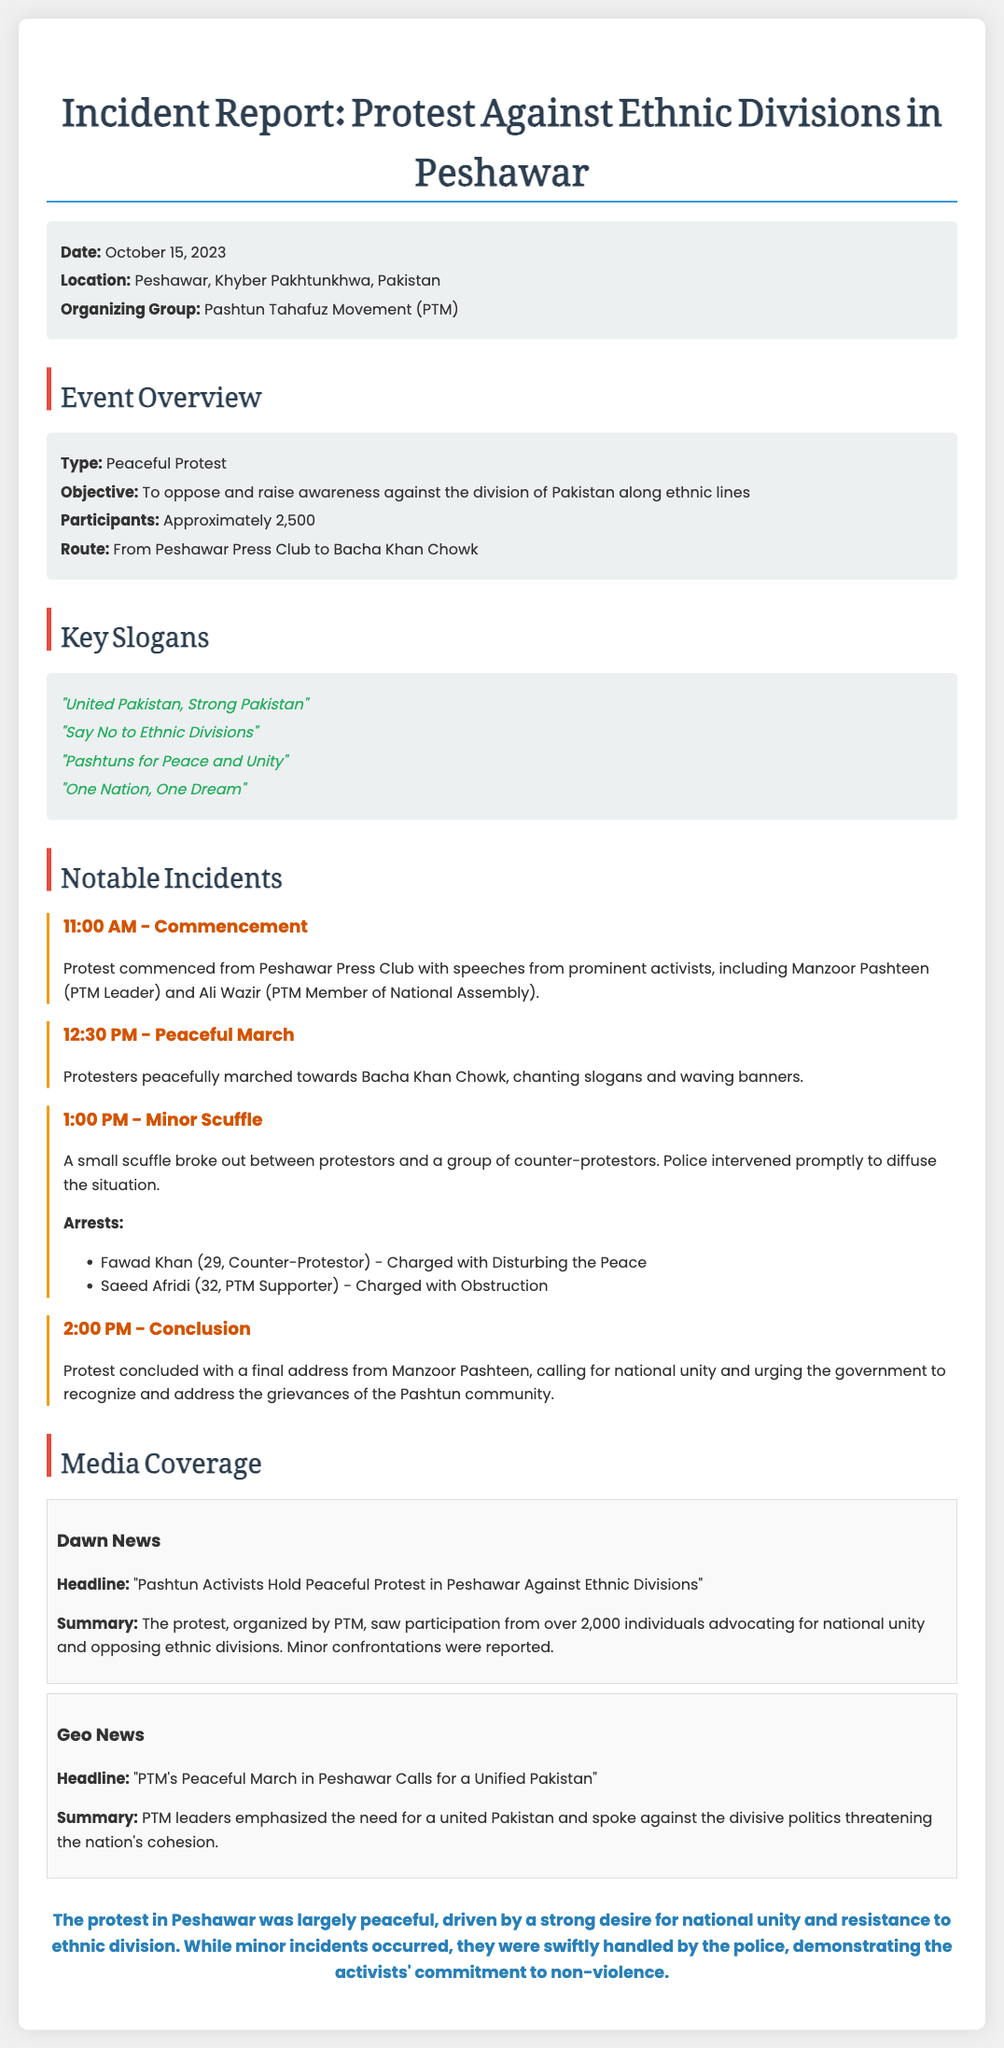What was the date of the protest? The date of the protest is mentioned at the beginning as October 15, 2023.
Answer: October 15, 2023 How many participants attended the protest? The number of participants is stated in the Event Overview section as approximately 2,500.
Answer: Approximately 2,500 Who is the leader of the PTM mentioned in the report? The report cites Manzoor Pashteen as the PTM Leader during the commencement of the protest.
Answer: Manzoor Pashteen What was the objective of the protest? The objective of the protest is specified as opposing and raising awareness against the division of Pakistan along ethnic lines.
Answer: To oppose and raise awareness against the division of Pakistan along ethnic lines What types of incidents occurred during the protest? The report notes that there was a minor scuffle and two arrests during the protest.
Answer: Minor scuffle and arrests Which location served as the starting point for the protest? The starting point of the protest is identified as the Peshawar Press Club in the document.
Answer: Peshawar Press Club What was one of the key slogans chanted by protesters? The report lists several slogans chanted, including "United Pakistan, Strong Pakistan."
Answer: "United Pakistan, Strong Pakistan" Who was arrested during the protest? The report enumerates two arrests, naming Fawad Khan and Saeed Afridi among them.
Answer: Fawad Khan and Saeed Afridi 